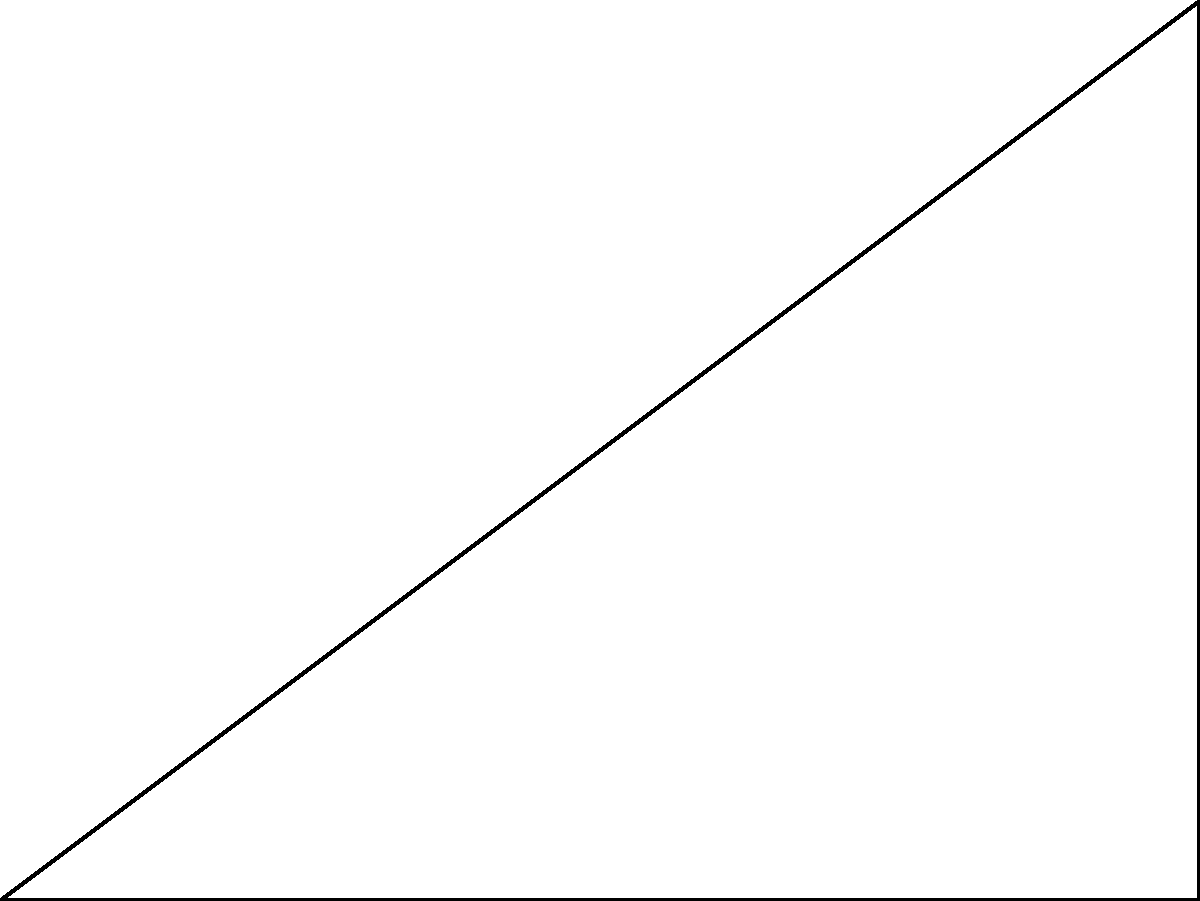As a relationship manager, you're designing a new advertisement banner for a business partner. The width of the banner is 8 units, and it forms a 30° angle with the horizontal base. Calculate the height of the banner to ensure it fits perfectly on the partner's website. To solve this problem, we'll use trigonometry, specifically the tangent function:

1) In a right triangle, $\tan \theta = \frac{\text{opposite}}{\text{adjacent}}$

2) Here, $\theta = 30°$, the adjacent side (width) $w = 8$ units, and we need to find the opposite side (height) $h$

3) We can write the equation:
   $\tan 30° = \frac{h}{8}$

4) Solve for $h$:
   $h = 8 \tan 30°$

5) We know that $\tan 30° = \frac{1}{\sqrt{3}}$, so:
   $h = 8 \cdot \frac{1}{\sqrt{3}}$

6) Simplify:
   $h = \frac{8}{\sqrt{3}} = \frac{8\sqrt{3}}{3}$

7) Calculate the numerical value:
   $h \approx 4.62$ units

Therefore, the height of the banner should be approximately 4.62 units.
Answer: $\frac{8\sqrt{3}}{3}$ units or approximately 4.62 units 